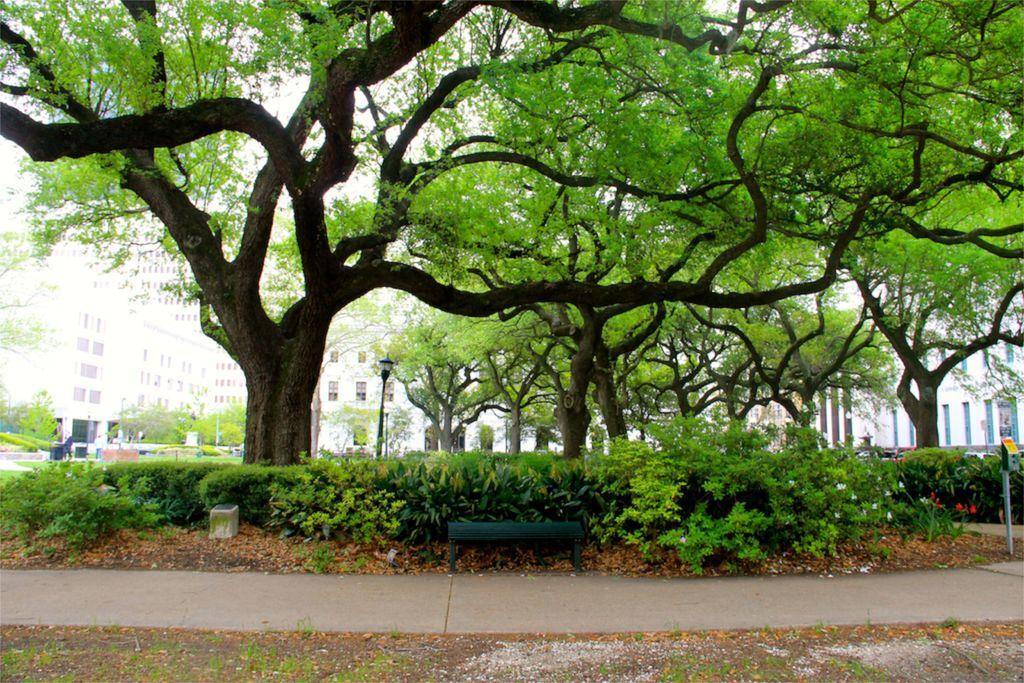Could you give a brief overview of what you see in this image? Here we can see a wooden bench,plants,trees and a pole. In the background there are buildings,windows,trees,light poles,some other items and sky. 